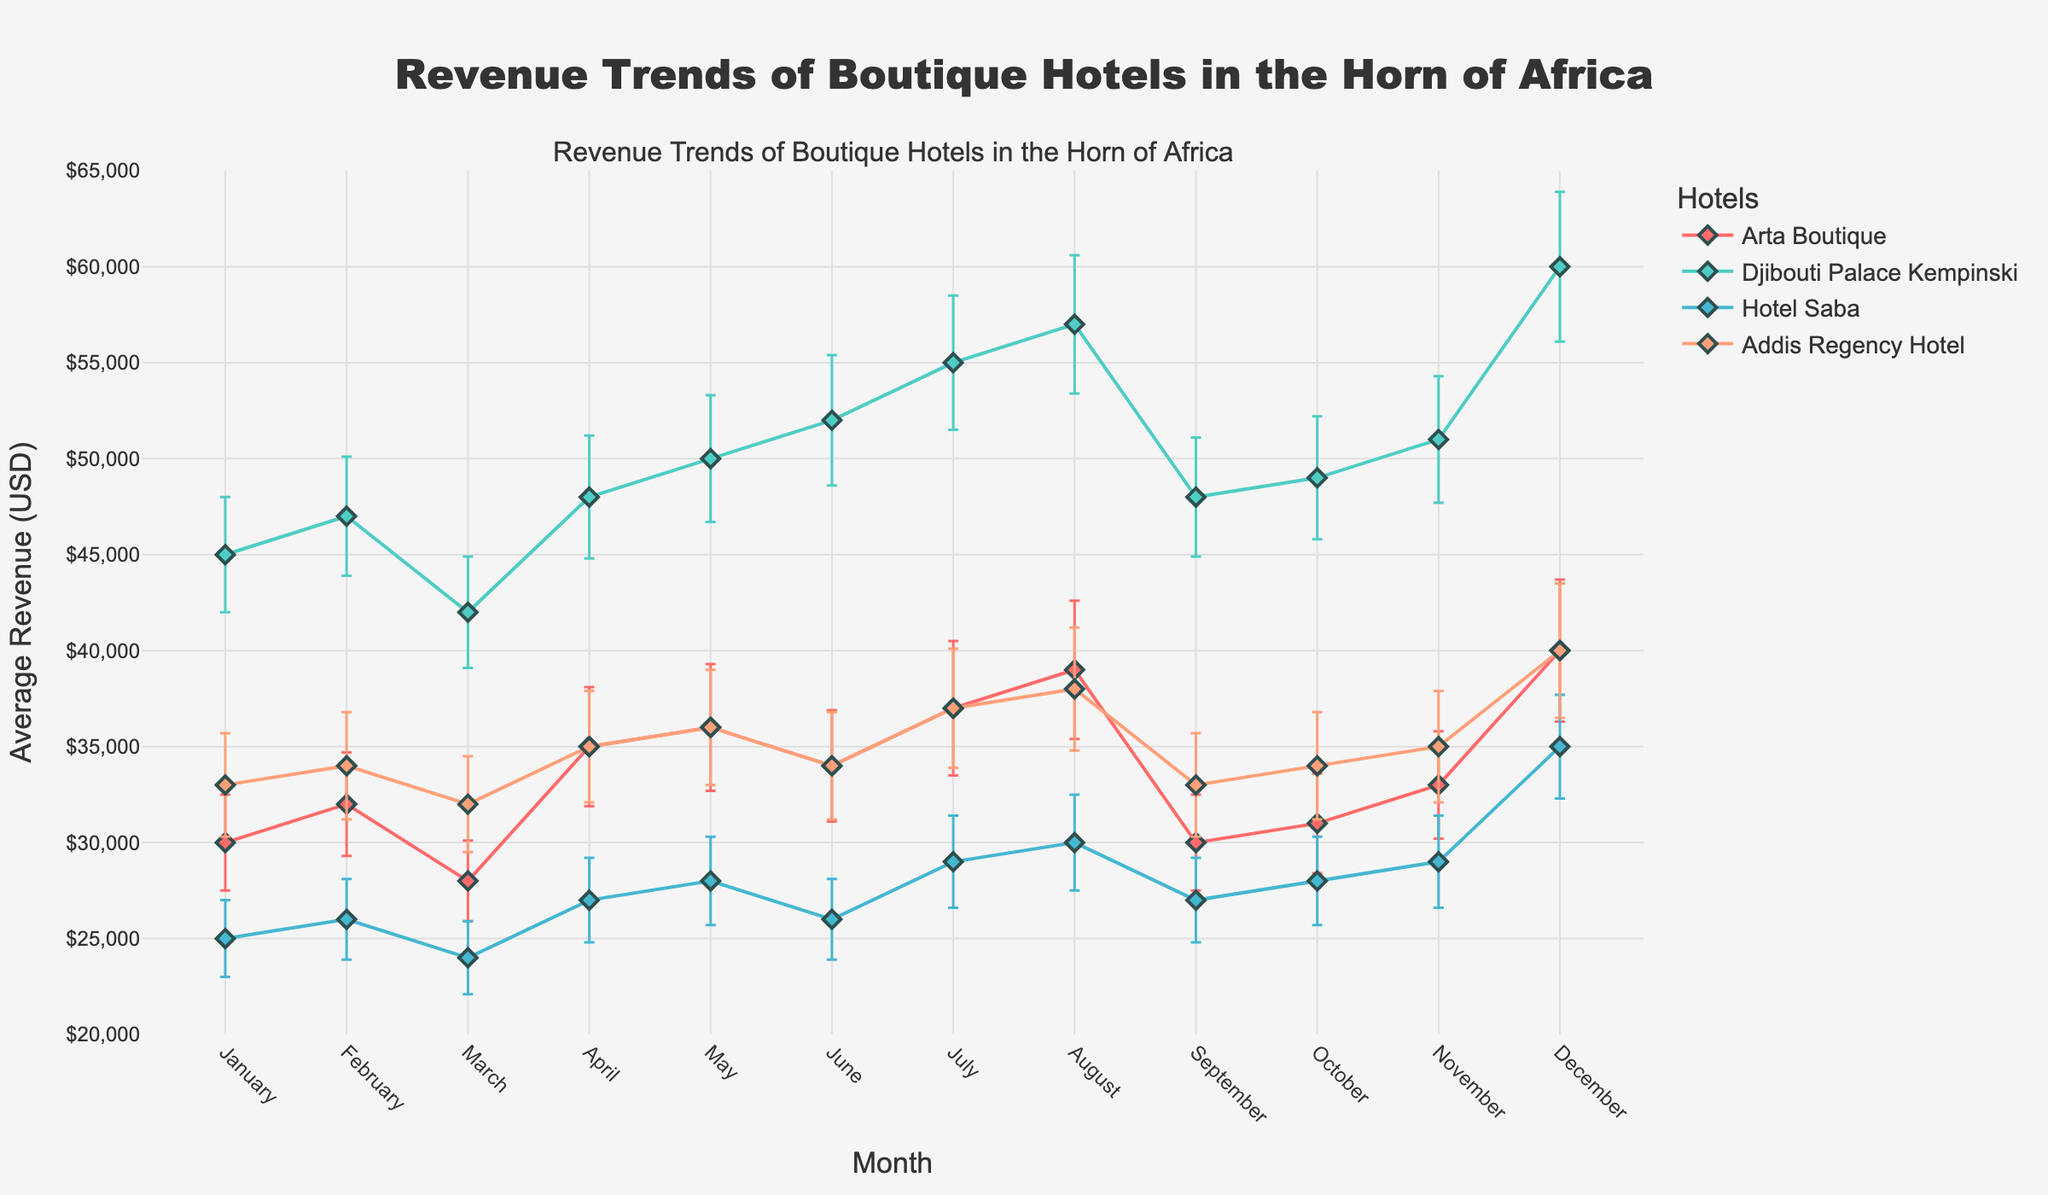Which month has the highest average revenue for Djibouti Palace Kempinski? To find the highest average revenue, look for the peak in the 'Djibouti Palace Kempinski' curve. The month with the highest point on this line is December, with an average revenue of $60,000.
Answer: December What's the average revenue for Arta Boutique in the first quarter of the year? Sum the revenues for January, February, and March: $30,000 (Jan) + $32,000 (Feb) + $28,000 (Mar) = $90,000. Then, divide by 3 to get the average: $90,000 / 3 = $30,000.
Answer: $30,000 How do the error bars in January compare across all hotels? In January, the error bars for each hotel are Arta Boutique ($2,500), Djibouti Palace Kempinski ($3,000), Hotel Saba ($2,000), and Addis Regency Hotel ($2,700). The error bar for Djibouti Palace Kempinski is the largest, and Hotel Saba's is the smallest.
Answer: Djibouti Palace Kempinski has the largest, Hotel Saba the smallest Which hotel shows the least seasonal variation in revenue? Seasonal variation can be observed through the range between the highest and lowest revenue points. Calculate the differences: 
Arta Boutique: $40,000 (Dec) - $28,000 (Mar) = $12,000, 
Djibouti Palace Kempinski: $60,000 (Dec) - $42,000 (Mar) = $18,000,
Hotel Saba: $35,000 (Dec) - $24,000 (Mar) = $11,000,
Addis Regency Hotel: $40,000 (Dec) - $32,000 (Mar) = $8,000.
Addis Regency Hotel has the lowest seasonal variation.
Answer: Addis Regency Hotel Do any of the hotels have the same average revenue in more than one month? Review the data points for each hotel:
- Arta Boutique: $30,000 in January and September
- Djibouti Palace Kempinski does not repeat any values
- Hotel Saba: $28,000 in October and May
- Addis Regency Hotel: $34,000 in February and October.
Thus, Arta Boutique, Hotel Saba, and Addis Regency Hotel each have repeated average revenues.
Answer: Yes, Arta Boutique, Hotel Saba, Addis Regency Hotel Which hotel has the greatest increase in revenue from January to December? Subtract January revenue from December revenue for each hotel:
- Arta Boutique: $40,000 - $30,000 = $10,000,
- Djibouti Palace Kempinski: $60,000 - $45,000 = $15,000,
- Hotel Saba: $35,000 - $25,000 = $10,000,
- Addis Regency Hotel: $40,000 - $33,000 = $7,000.
Djibouti Palace Kempinski shows the greatest increase.
Answer: Djibouti Palace Kempinski What is the revenue trend for Hotel Saba from July to December? Starting from July, the revenues are: $29,000 (July), $30,000 (August), $27,000 (September), $28,000 (October), $29,000 (November), $35,000 (December). It shows a steady trend until a sharp increase in December.
Answer: Steady, then sharp increase in December 